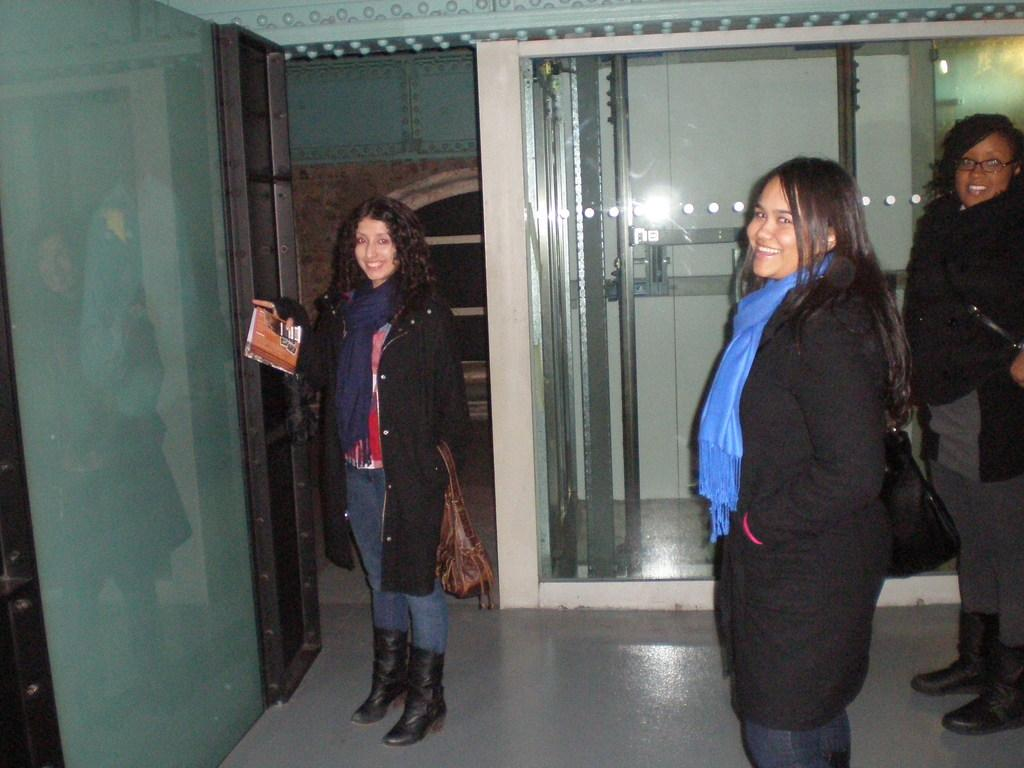How many women are in the image? There are three women in the image. What are the women doing in the image? The women are standing and smiling. Can you describe the woman on the left? The woman on the left is holding a paper. What architectural feature can be seen in the image? There are glass doors in the image. What type of curtain is hanging in front of the glass doors in the image? There are no curtains present in the image; only glass doors are visible. What note is the woman on the right singing in the image? There is no indication that the women are singing or that there is a note involved in the image. 